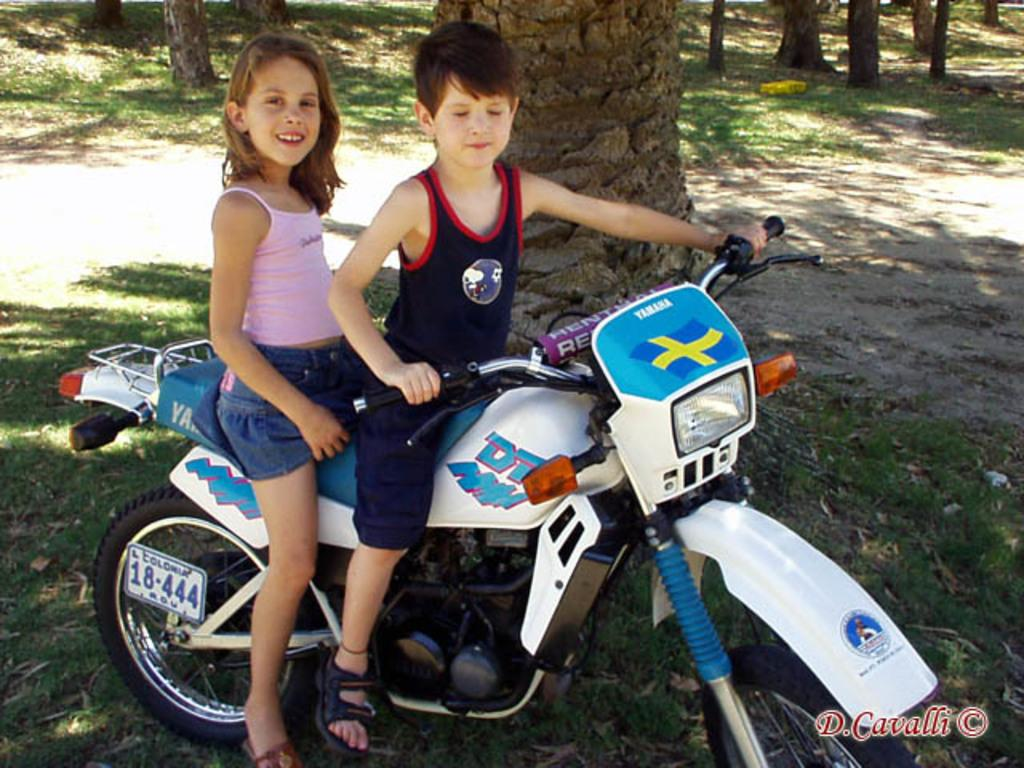How many kids are in the image? There are two kids in the image. What are the kids doing in the image? The kids are seated on a bike. Can you describe the position of the girl in the image? The girl is seated on the back side of the bike. What is the girl's expression in the image? The girl is smiling. What can be seen in the background of the image? There is grass and trees in the background of the image. What type of army scene can be seen in the image? There is no army scene present in the image; it features two kids seated on a bike with a smiling girl in the background. 